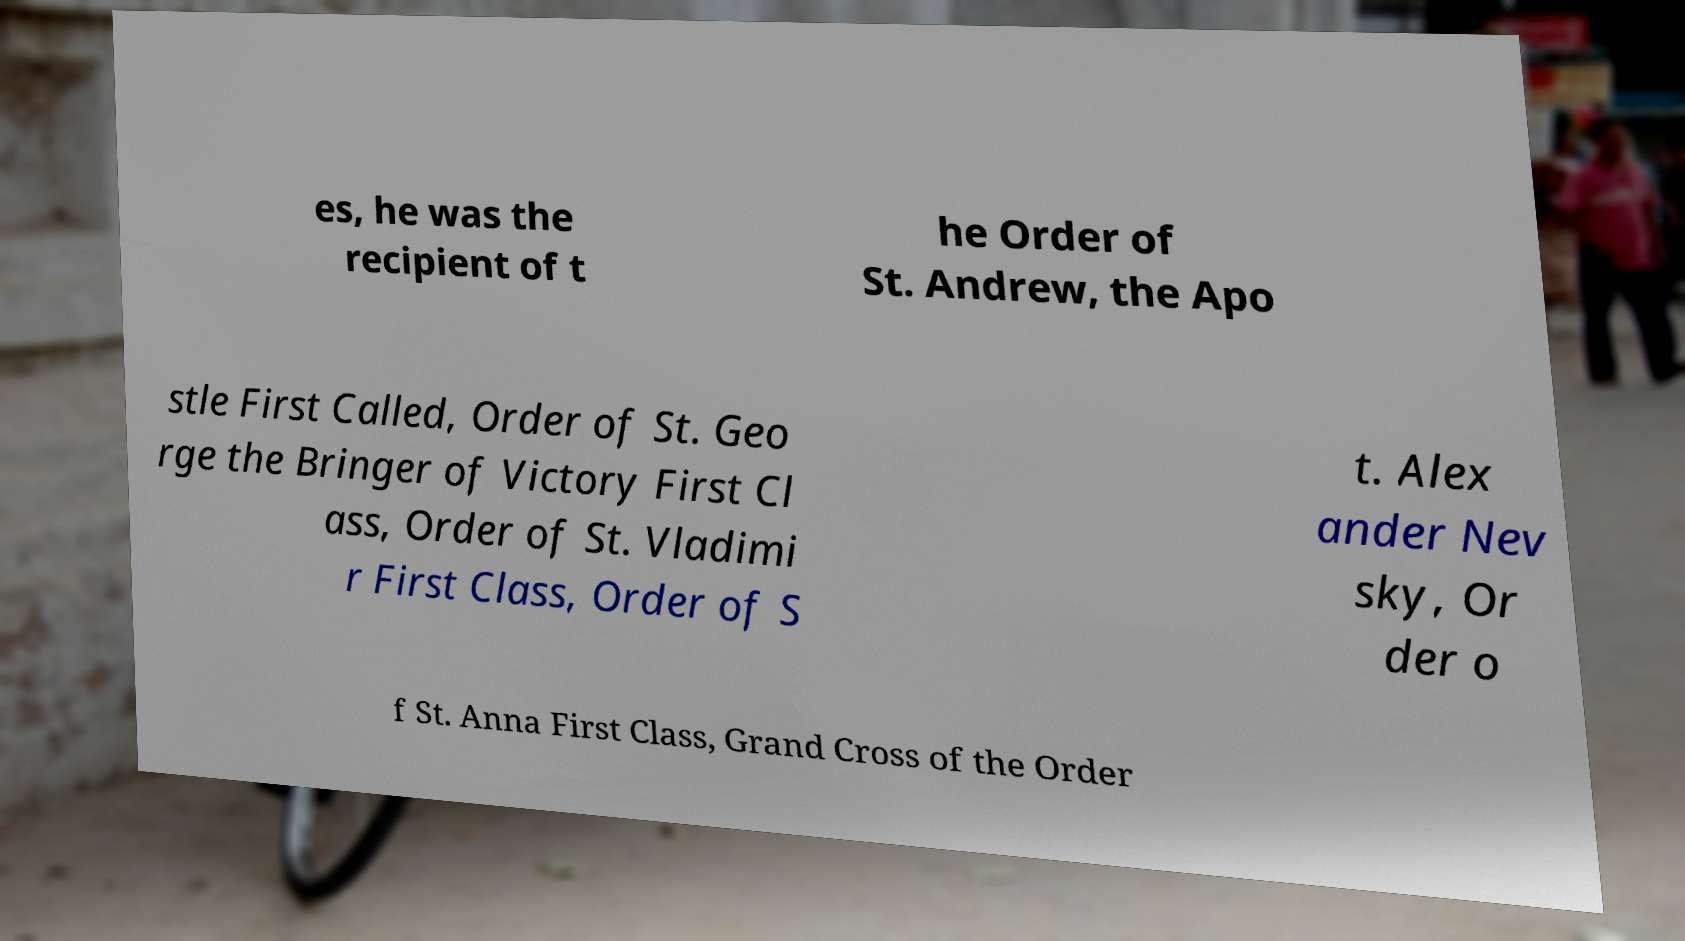What messages or text are displayed in this image? I need them in a readable, typed format. es, he was the recipient of t he Order of St. Andrew, the Apo stle First Called, Order of St. Geo rge the Bringer of Victory First Cl ass, Order of St. Vladimi r First Class, Order of S t. Alex ander Nev sky, Or der o f St. Anna First Class, Grand Cross of the Order 